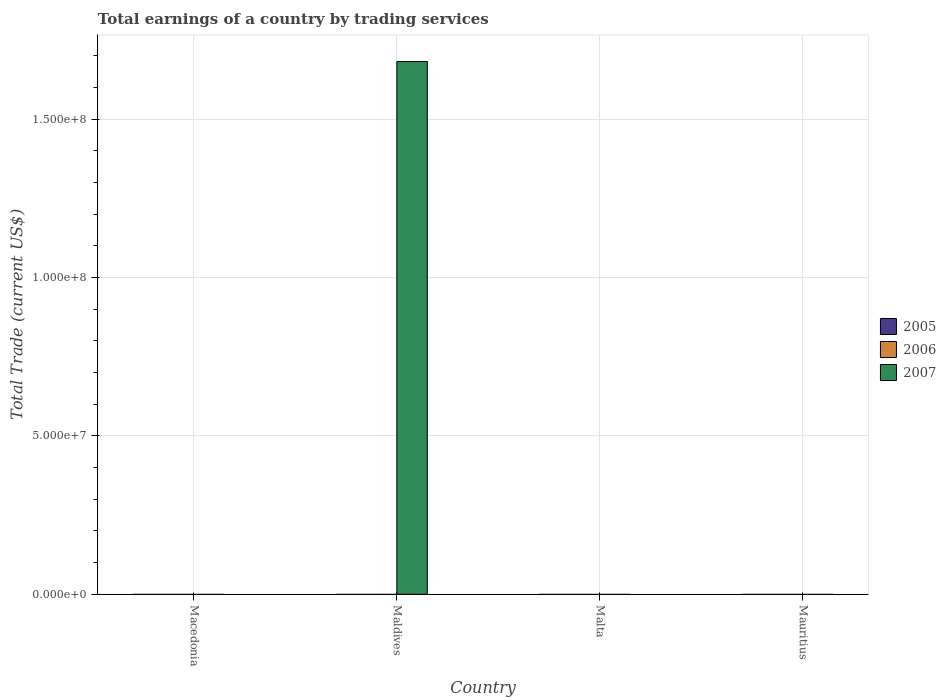Are the number of bars on each tick of the X-axis equal?
Your answer should be very brief. No. How many bars are there on the 2nd tick from the left?
Offer a terse response. 1. What is the label of the 2nd group of bars from the left?
Provide a succinct answer. Maldives. What is the total earnings in 2007 in Macedonia?
Your answer should be very brief. 0. Across all countries, what is the maximum total earnings in 2007?
Make the answer very short. 1.68e+08. In which country was the total earnings in 2007 maximum?
Provide a succinct answer. Maldives. What is the total total earnings in 2006 in the graph?
Keep it short and to the point. 0. What is the difference between the total earnings in 2006 in Malta and the total earnings in 2007 in Macedonia?
Provide a succinct answer. 0. In how many countries, is the total earnings in 2005 greater than 10000000 US$?
Keep it short and to the point. 0. What is the difference between the highest and the lowest total earnings in 2007?
Make the answer very short. 1.68e+08. In how many countries, is the total earnings in 2007 greater than the average total earnings in 2007 taken over all countries?
Make the answer very short. 1. Is it the case that in every country, the sum of the total earnings in 2007 and total earnings in 2006 is greater than the total earnings in 2005?
Offer a very short reply. No. How many bars are there?
Your answer should be compact. 1. Are all the bars in the graph horizontal?
Offer a terse response. No. How many legend labels are there?
Your response must be concise. 3. What is the title of the graph?
Provide a short and direct response. Total earnings of a country by trading services. Does "2012" appear as one of the legend labels in the graph?
Make the answer very short. No. What is the label or title of the X-axis?
Give a very brief answer. Country. What is the label or title of the Y-axis?
Offer a terse response. Total Trade (current US$). What is the Total Trade (current US$) in 2007 in Macedonia?
Provide a succinct answer. 0. What is the Total Trade (current US$) of 2005 in Maldives?
Your response must be concise. 0. What is the Total Trade (current US$) in 2007 in Maldives?
Offer a terse response. 1.68e+08. What is the Total Trade (current US$) of 2006 in Malta?
Your answer should be compact. 0. What is the Total Trade (current US$) of 2007 in Mauritius?
Offer a very short reply. 0. Across all countries, what is the maximum Total Trade (current US$) in 2007?
Make the answer very short. 1.68e+08. What is the total Total Trade (current US$) of 2007 in the graph?
Provide a short and direct response. 1.68e+08. What is the average Total Trade (current US$) in 2005 per country?
Ensure brevity in your answer.  0. What is the average Total Trade (current US$) in 2007 per country?
Ensure brevity in your answer.  4.20e+07. What is the difference between the highest and the lowest Total Trade (current US$) in 2007?
Your response must be concise. 1.68e+08. 